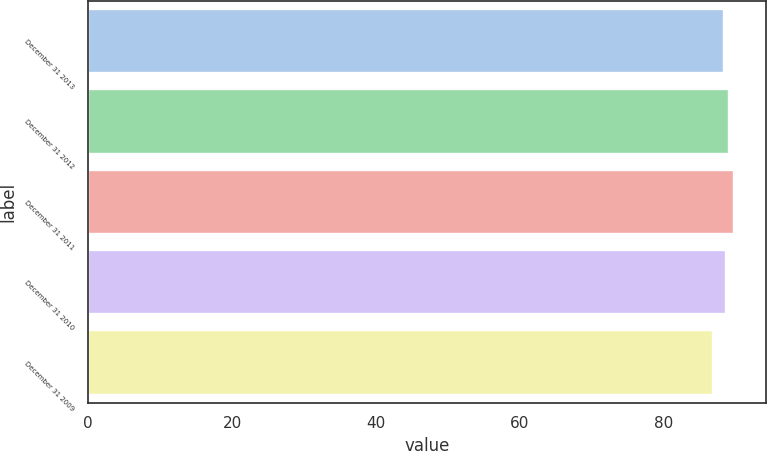<chart> <loc_0><loc_0><loc_500><loc_500><bar_chart><fcel>December 31 2013<fcel>December 31 2012<fcel>December 31 2011<fcel>December 31 2010<fcel>December 31 2009<nl><fcel>88.3<fcel>89.1<fcel>89.7<fcel>88.6<fcel>86.8<nl></chart> 